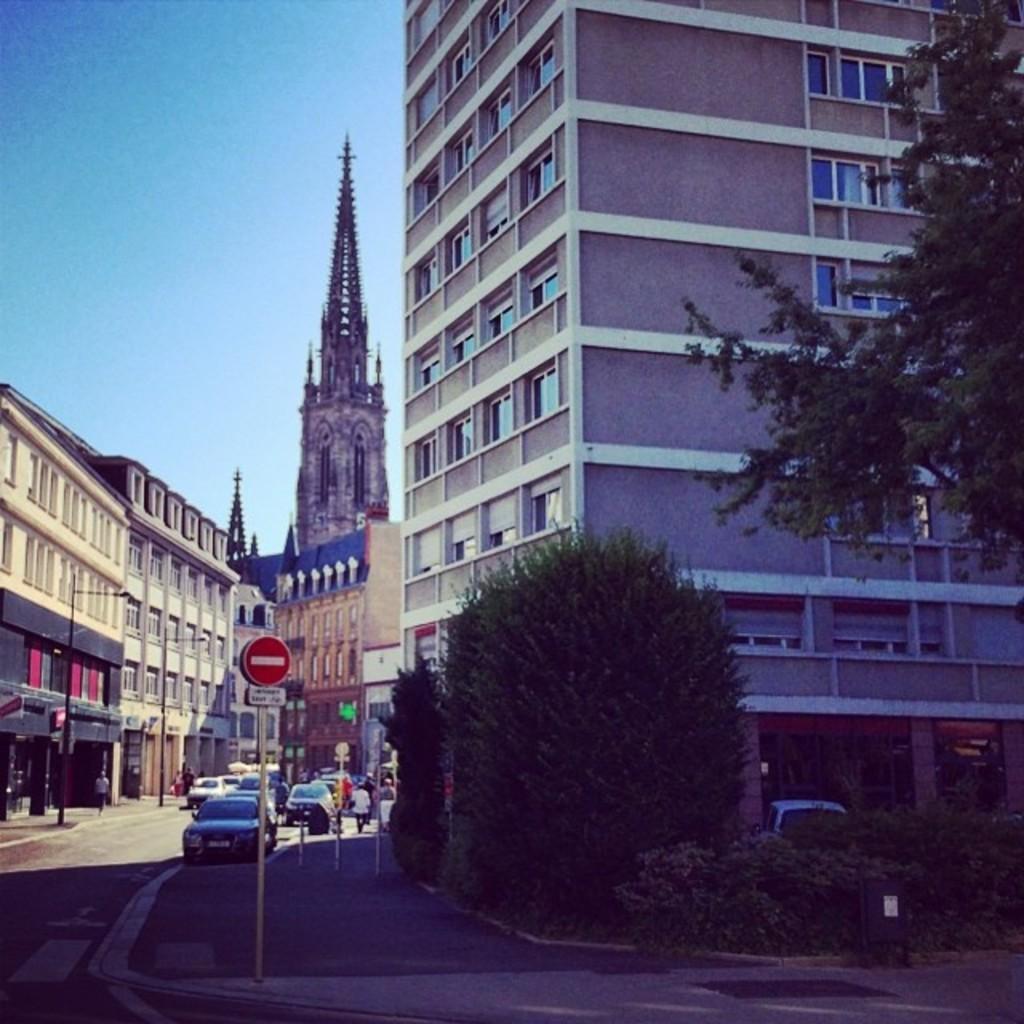How would you summarize this image in a sentence or two? In this image we can see trees, plants, boards on a pole, vehicles on the road, few persons, buildings, windows, objects and sky. 